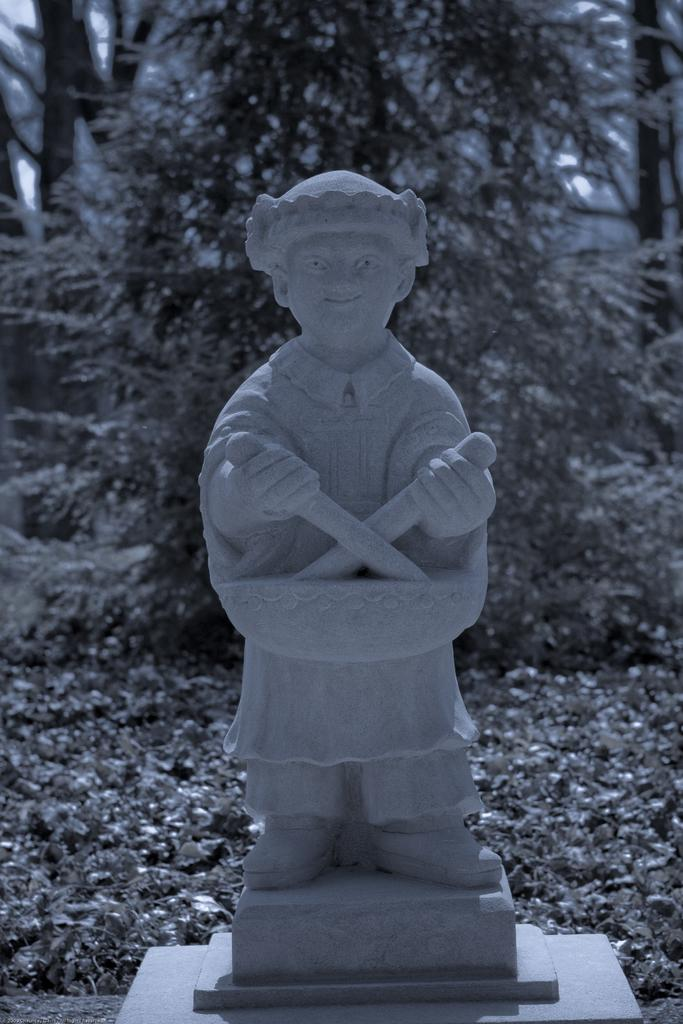What is the main subject of the image? There is a sculpture of a man in the image. What is the man holding in his hand? The man is holding knives in his hand. What can be seen in the background of the image? There are trees visible behind the sculpture. How are the trees positioned in relation to the sculpture? The trees are on the ground behind the sculpture. What type of goat is standing next to the man in the image? There is no goat present in the image; it features a sculpture of a man holding knives with trees in the background. What color is the man's shirt in the image? The image is of a sculpture, so it does not have a shirt or any color associated with it. 